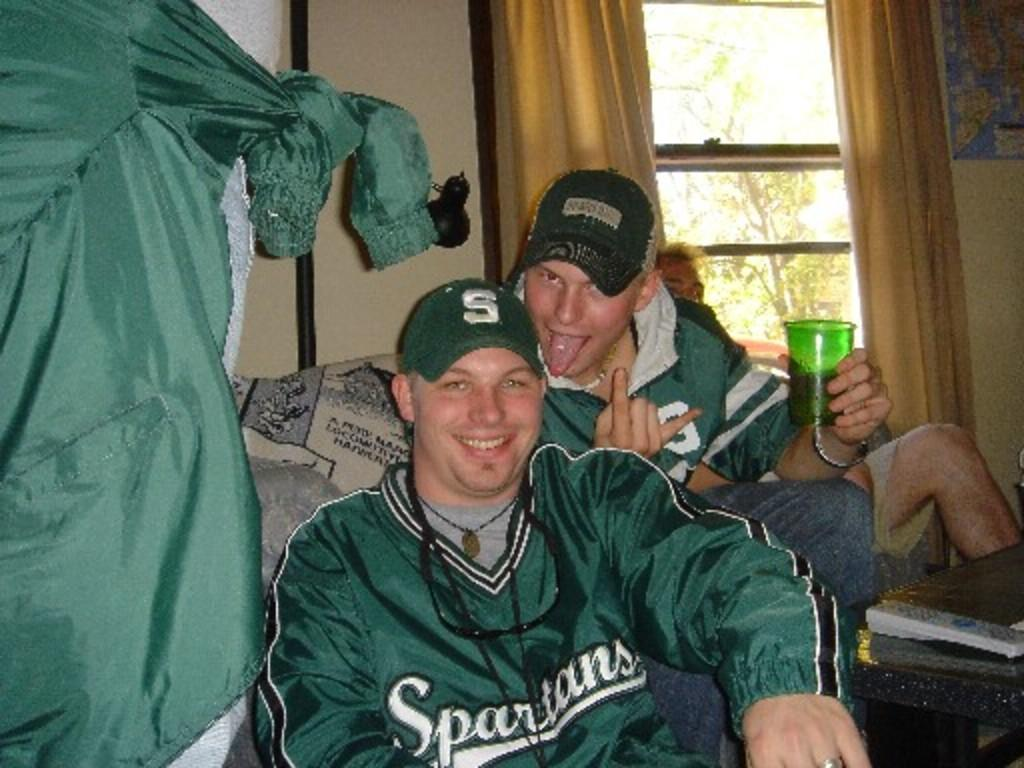Provide a one-sentence caption for the provided image. Two boys wear green Spartans  shirts and jackets. 